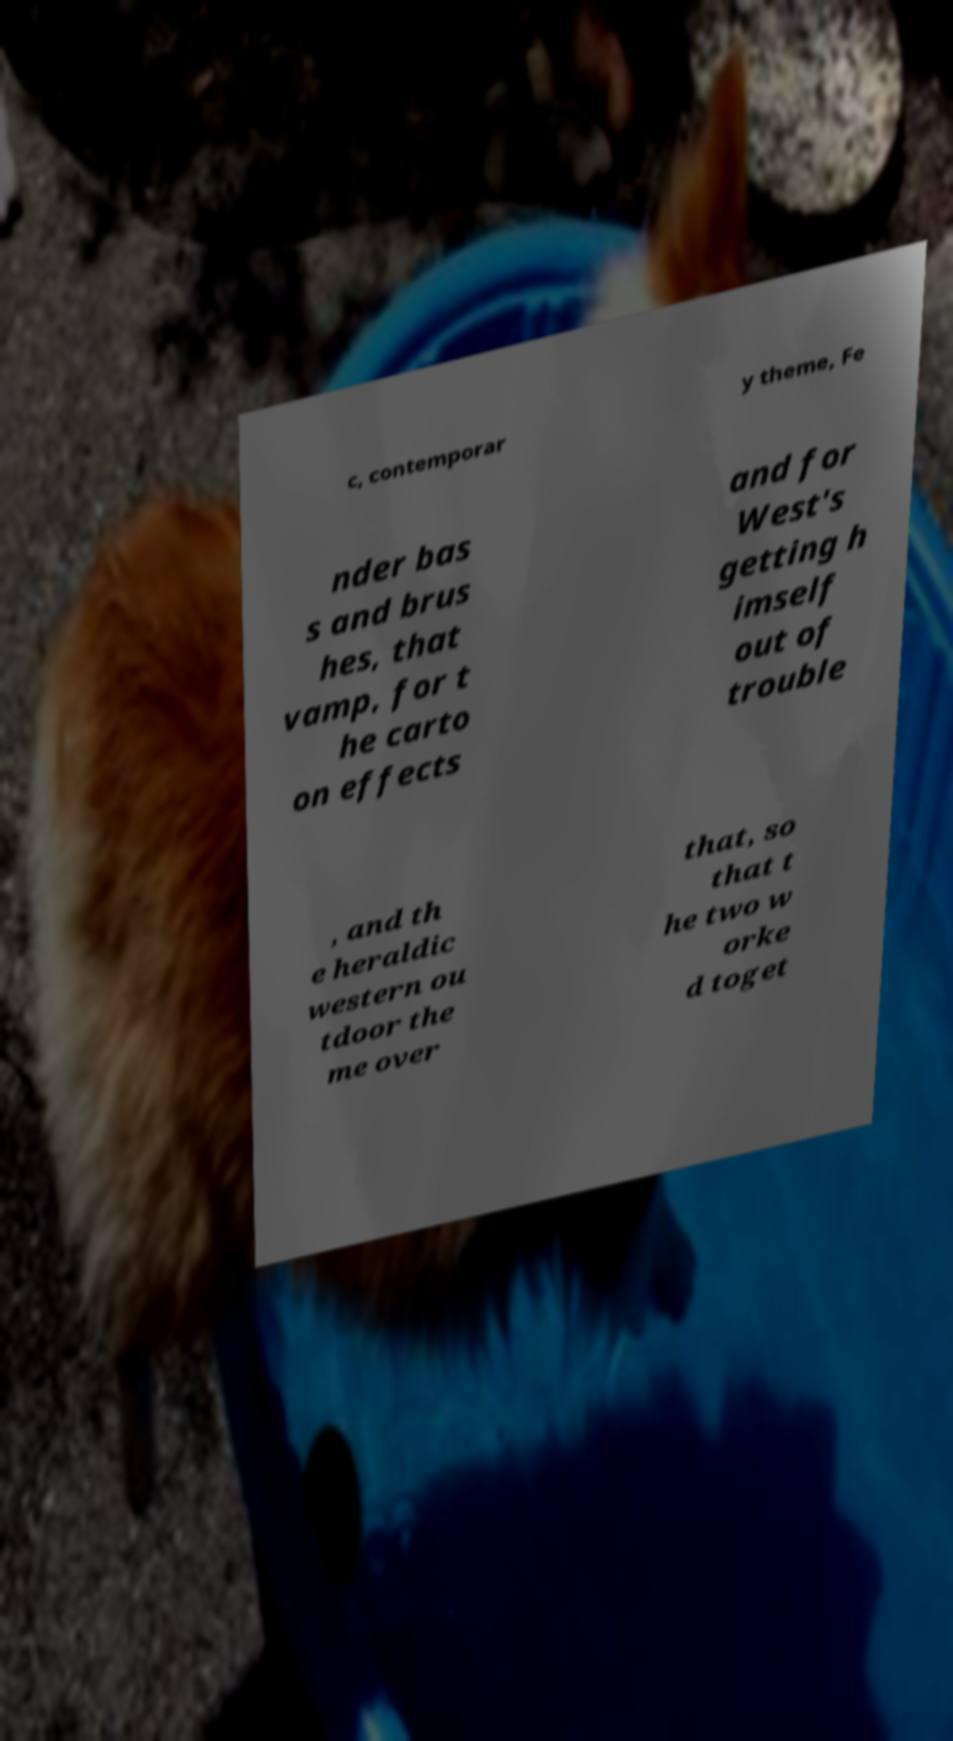I need the written content from this picture converted into text. Can you do that? c, contemporar y theme, Fe nder bas s and brus hes, that vamp, for t he carto on effects and for West's getting h imself out of trouble , and th e heraldic western ou tdoor the me over that, so that t he two w orke d toget 